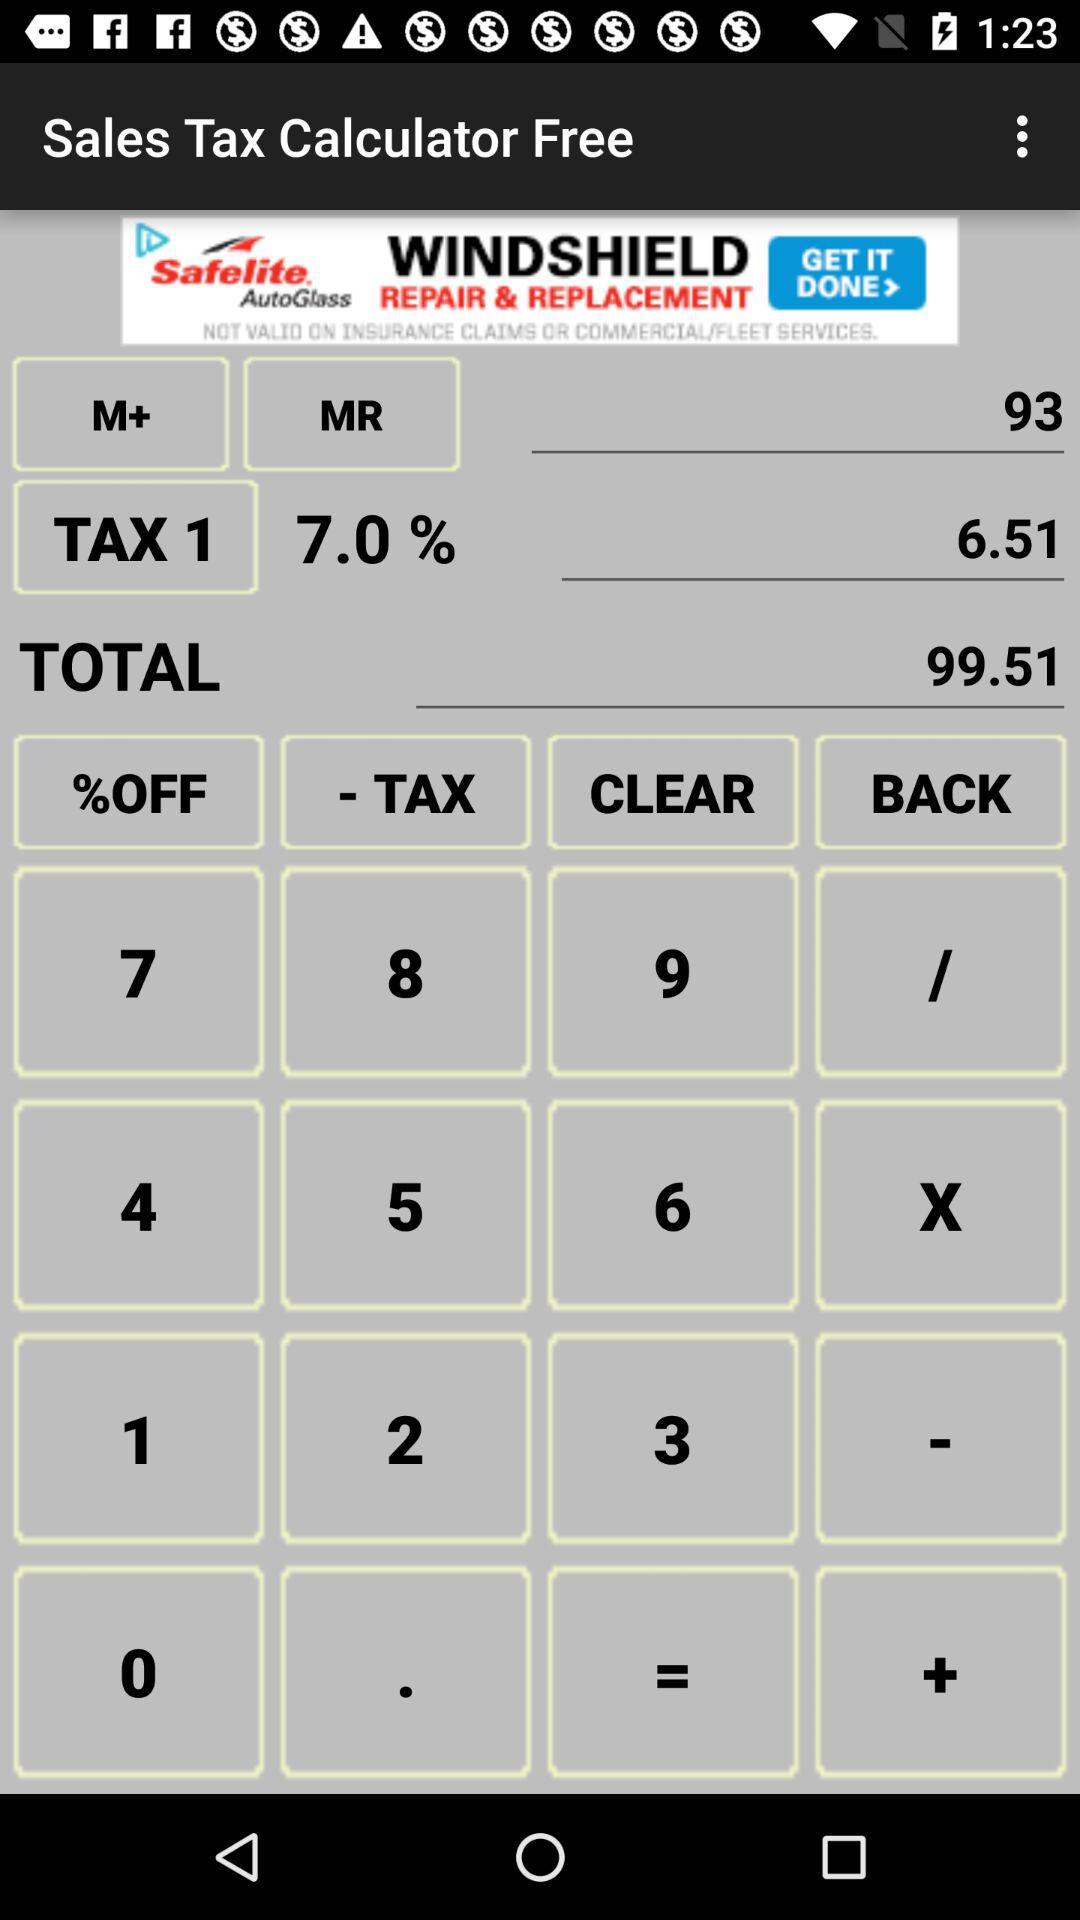What is the "TAX 1" amount? The "TAX 1" amount is 6.51. 